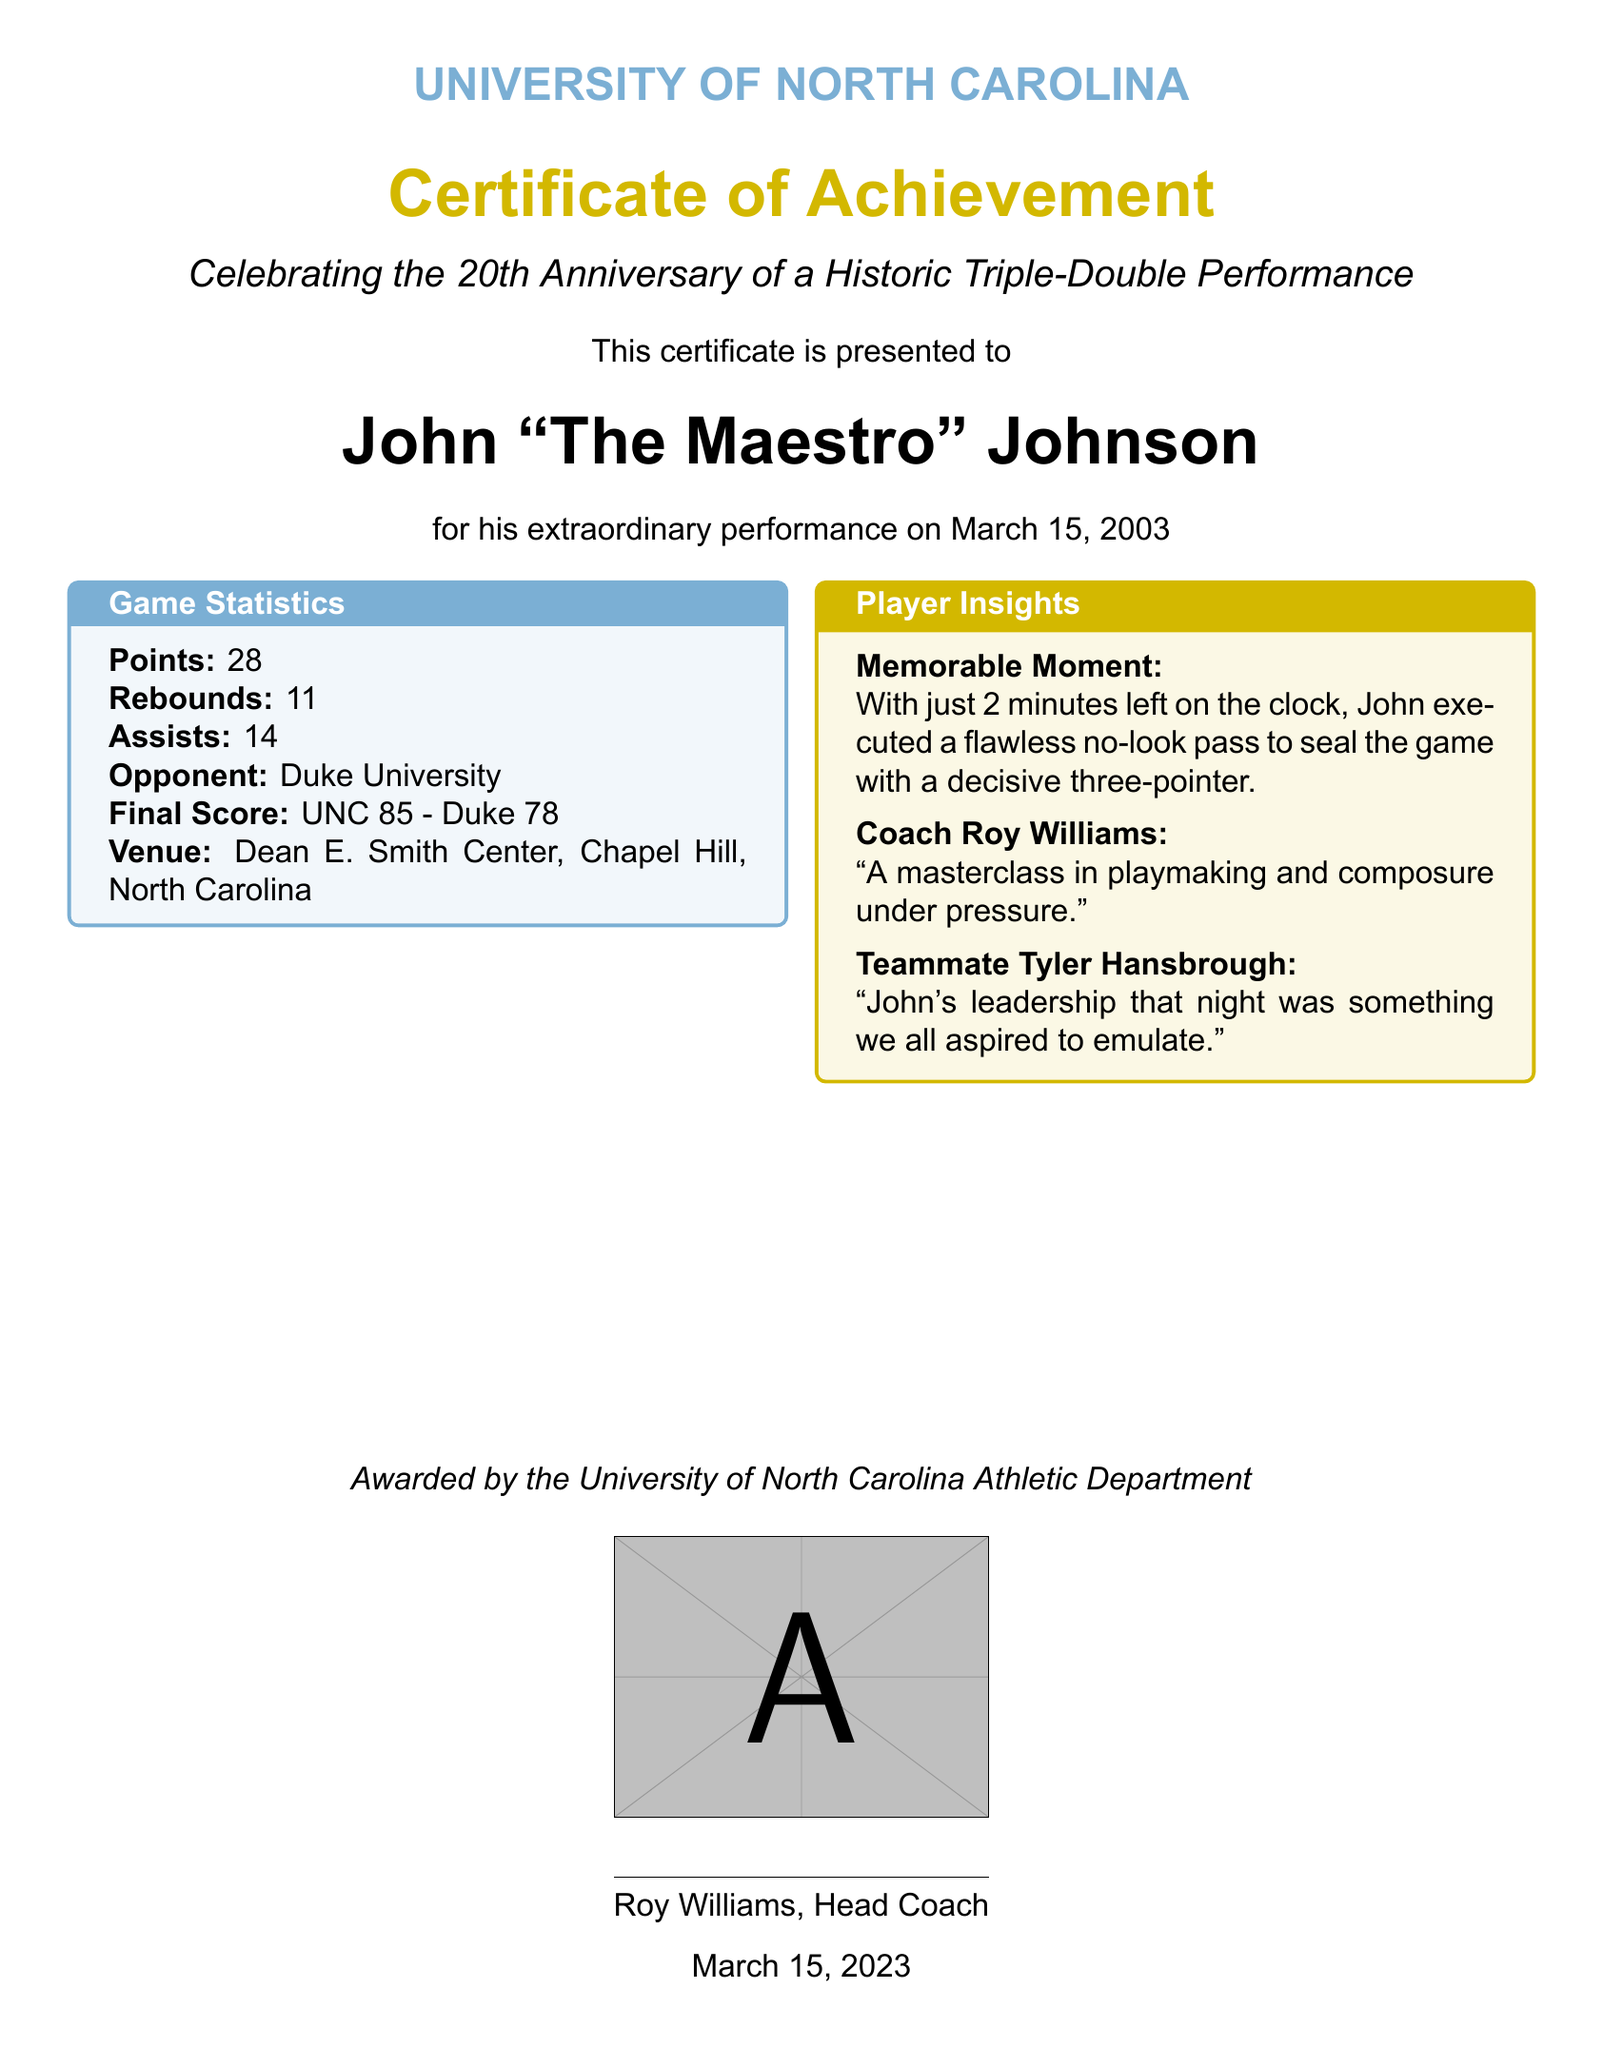What is the name of the player honored in the certificate? The player's name is presented prominently in the certificate as the recipient of the award.
Answer: John "The Maestro" Johnson What date is the certificate awarded? The date of the award is mentioned at the bottom of the document, indicating when the certificate was presented.
Answer: March 15, 2023 What was the final score of the game? The final score is highlighted in the game statistics section, detailing the outcome of the match.
Answer: UNC 85 - Duke 78 How many assists did John achieve during the game? The number of assists is listed in the game statistics, showing the player's contribution in this area.
Answer: 14 What venue hosted the historic performance? The venue is specified in the game statistics, indicating where the event took place.
Answer: Dean E. Smith Center, Chapel Hill, North Carolina Who was the opponent team in this game? The opponent team is clearly mentioned in the game statistics as part of the match details.
Answer: Duke University What compliment did Coach Roy Williams give about John's performance? The quote from Coach Roy Williams provides insight into the coach's perspective on the player's game.
Answer: A masterclass in playmaking and composure under pressure What notable moment is highlighted in the player insights? The memorable moment mentioned describes a key play that contributed significantly to the game's outcome.
Answer: Flawless no-look pass to seal the game with a decisive three-pointer 